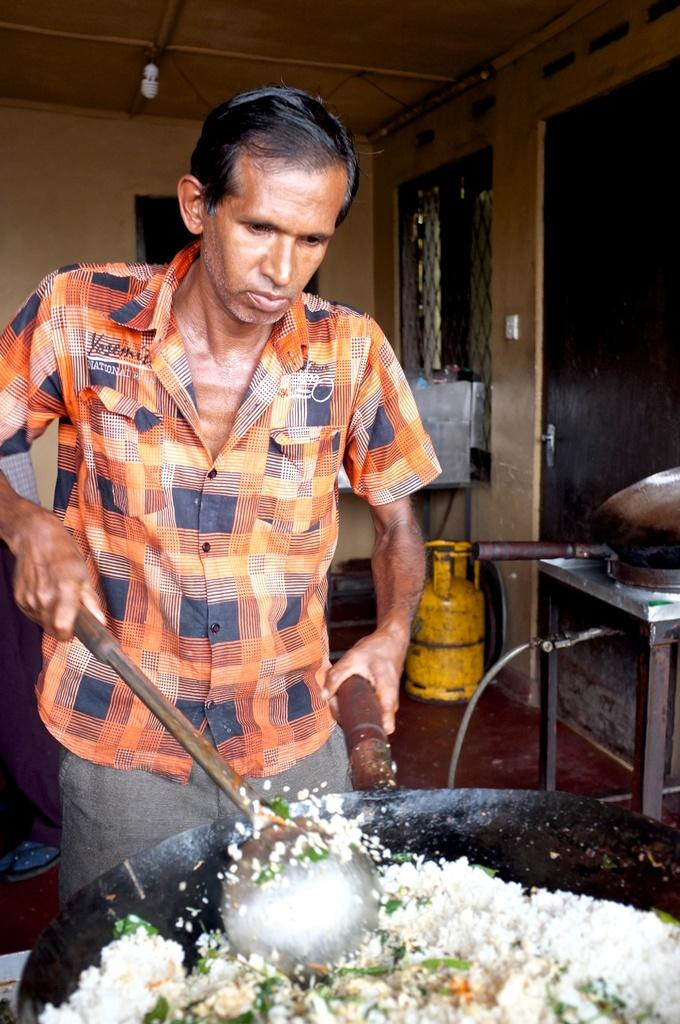What is the man in the image doing? The man is cooking in the image. What is the man holding in his hand? The man is holding a spoon in his hand. What can be seen in the background of the image? There is a wall, a cylinder, a table, and a light in the background of the image. What type of disease is the man suffering from in the image? There is no indication of any disease in the image; the man is simply cooking. Can you tell me how many branches are visible in the image? There are no branches present in the image. 